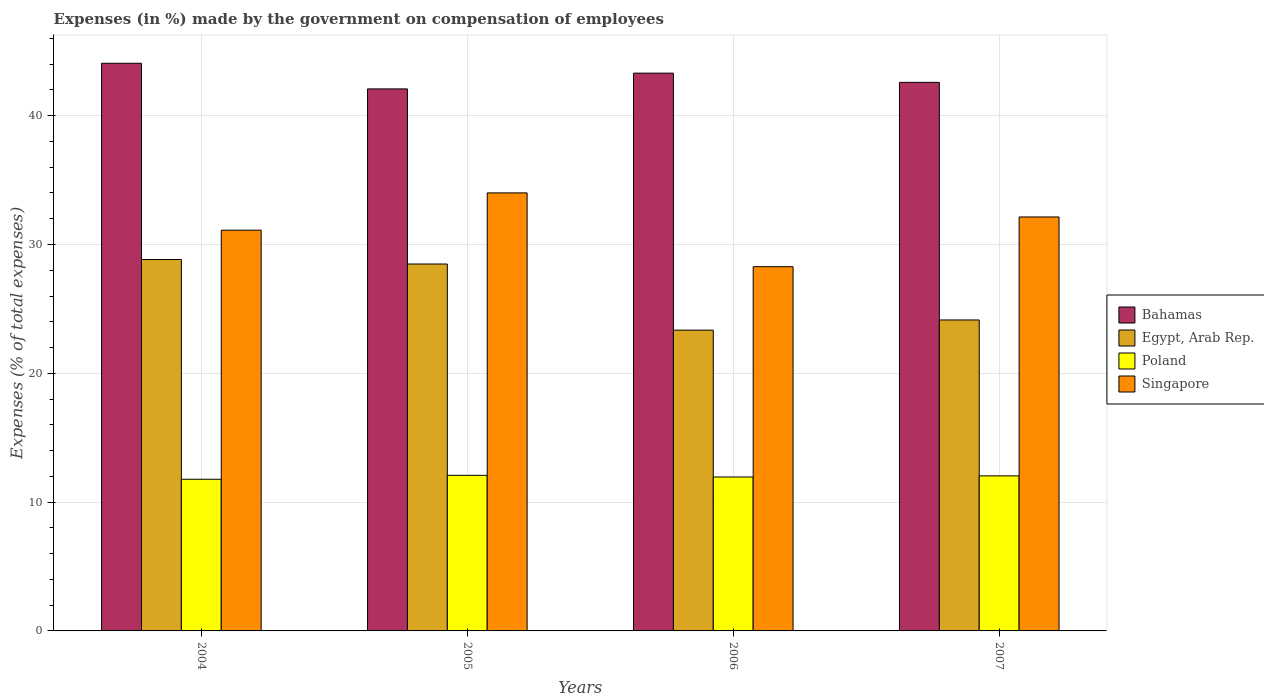How many different coloured bars are there?
Your response must be concise. 4. Are the number of bars on each tick of the X-axis equal?
Your answer should be compact. Yes. How many bars are there on the 1st tick from the left?
Provide a succinct answer. 4. How many bars are there on the 4th tick from the right?
Offer a very short reply. 4. What is the label of the 1st group of bars from the left?
Ensure brevity in your answer.  2004. In how many cases, is the number of bars for a given year not equal to the number of legend labels?
Your answer should be very brief. 0. What is the percentage of expenses made by the government on compensation of employees in Egypt, Arab Rep. in 2006?
Make the answer very short. 23.35. Across all years, what is the maximum percentage of expenses made by the government on compensation of employees in Bahamas?
Give a very brief answer. 44.07. Across all years, what is the minimum percentage of expenses made by the government on compensation of employees in Singapore?
Your answer should be compact. 28.28. In which year was the percentage of expenses made by the government on compensation of employees in Singapore minimum?
Give a very brief answer. 2006. What is the total percentage of expenses made by the government on compensation of employees in Egypt, Arab Rep. in the graph?
Your answer should be very brief. 104.81. What is the difference between the percentage of expenses made by the government on compensation of employees in Bahamas in 2005 and that in 2006?
Offer a very short reply. -1.22. What is the difference between the percentage of expenses made by the government on compensation of employees in Bahamas in 2007 and the percentage of expenses made by the government on compensation of employees in Singapore in 2006?
Make the answer very short. 14.31. What is the average percentage of expenses made by the government on compensation of employees in Singapore per year?
Provide a succinct answer. 31.38. In the year 2005, what is the difference between the percentage of expenses made by the government on compensation of employees in Poland and percentage of expenses made by the government on compensation of employees in Egypt, Arab Rep.?
Your response must be concise. -16.4. In how many years, is the percentage of expenses made by the government on compensation of employees in Egypt, Arab Rep. greater than 20 %?
Provide a succinct answer. 4. What is the ratio of the percentage of expenses made by the government on compensation of employees in Poland in 2006 to that in 2007?
Offer a terse response. 0.99. Is the percentage of expenses made by the government on compensation of employees in Bahamas in 2004 less than that in 2007?
Give a very brief answer. No. What is the difference between the highest and the second highest percentage of expenses made by the government on compensation of employees in Singapore?
Provide a short and direct response. 1.87. What is the difference between the highest and the lowest percentage of expenses made by the government on compensation of employees in Poland?
Make the answer very short. 0.31. Is the sum of the percentage of expenses made by the government on compensation of employees in Bahamas in 2004 and 2007 greater than the maximum percentage of expenses made by the government on compensation of employees in Singapore across all years?
Your answer should be compact. Yes. What does the 4th bar from the right in 2007 represents?
Your answer should be very brief. Bahamas. Are all the bars in the graph horizontal?
Your answer should be compact. No. Are the values on the major ticks of Y-axis written in scientific E-notation?
Give a very brief answer. No. Does the graph contain any zero values?
Keep it short and to the point. No. Where does the legend appear in the graph?
Keep it short and to the point. Center right. How many legend labels are there?
Offer a very short reply. 4. How are the legend labels stacked?
Your answer should be compact. Vertical. What is the title of the graph?
Give a very brief answer. Expenses (in %) made by the government on compensation of employees. What is the label or title of the Y-axis?
Give a very brief answer. Expenses (% of total expenses). What is the Expenses (% of total expenses) in Bahamas in 2004?
Your response must be concise. 44.07. What is the Expenses (% of total expenses) of Egypt, Arab Rep. in 2004?
Give a very brief answer. 28.84. What is the Expenses (% of total expenses) in Poland in 2004?
Keep it short and to the point. 11.77. What is the Expenses (% of total expenses) in Singapore in 2004?
Offer a terse response. 31.11. What is the Expenses (% of total expenses) in Bahamas in 2005?
Keep it short and to the point. 42.08. What is the Expenses (% of total expenses) of Egypt, Arab Rep. in 2005?
Ensure brevity in your answer.  28.48. What is the Expenses (% of total expenses) in Poland in 2005?
Your answer should be very brief. 12.08. What is the Expenses (% of total expenses) in Singapore in 2005?
Keep it short and to the point. 34.01. What is the Expenses (% of total expenses) of Bahamas in 2006?
Your answer should be compact. 43.3. What is the Expenses (% of total expenses) in Egypt, Arab Rep. in 2006?
Give a very brief answer. 23.35. What is the Expenses (% of total expenses) of Poland in 2006?
Provide a succinct answer. 11.95. What is the Expenses (% of total expenses) of Singapore in 2006?
Your answer should be very brief. 28.28. What is the Expenses (% of total expenses) of Bahamas in 2007?
Your answer should be compact. 42.59. What is the Expenses (% of total expenses) in Egypt, Arab Rep. in 2007?
Provide a succinct answer. 24.14. What is the Expenses (% of total expenses) in Poland in 2007?
Your response must be concise. 12.04. What is the Expenses (% of total expenses) in Singapore in 2007?
Offer a very short reply. 32.14. Across all years, what is the maximum Expenses (% of total expenses) in Bahamas?
Your answer should be very brief. 44.07. Across all years, what is the maximum Expenses (% of total expenses) of Egypt, Arab Rep.?
Make the answer very short. 28.84. Across all years, what is the maximum Expenses (% of total expenses) in Poland?
Provide a succinct answer. 12.08. Across all years, what is the maximum Expenses (% of total expenses) of Singapore?
Offer a very short reply. 34.01. Across all years, what is the minimum Expenses (% of total expenses) of Bahamas?
Provide a succinct answer. 42.08. Across all years, what is the minimum Expenses (% of total expenses) in Egypt, Arab Rep.?
Offer a very short reply. 23.35. Across all years, what is the minimum Expenses (% of total expenses) of Poland?
Provide a succinct answer. 11.77. Across all years, what is the minimum Expenses (% of total expenses) of Singapore?
Give a very brief answer. 28.28. What is the total Expenses (% of total expenses) of Bahamas in the graph?
Keep it short and to the point. 172.04. What is the total Expenses (% of total expenses) in Egypt, Arab Rep. in the graph?
Ensure brevity in your answer.  104.81. What is the total Expenses (% of total expenses) in Poland in the graph?
Offer a very short reply. 47.84. What is the total Expenses (% of total expenses) in Singapore in the graph?
Your answer should be very brief. 125.53. What is the difference between the Expenses (% of total expenses) in Bahamas in 2004 and that in 2005?
Keep it short and to the point. 1.99. What is the difference between the Expenses (% of total expenses) of Egypt, Arab Rep. in 2004 and that in 2005?
Keep it short and to the point. 0.35. What is the difference between the Expenses (% of total expenses) in Poland in 2004 and that in 2005?
Keep it short and to the point. -0.31. What is the difference between the Expenses (% of total expenses) in Singapore in 2004 and that in 2005?
Make the answer very short. -2.89. What is the difference between the Expenses (% of total expenses) of Bahamas in 2004 and that in 2006?
Your answer should be compact. 0.77. What is the difference between the Expenses (% of total expenses) of Egypt, Arab Rep. in 2004 and that in 2006?
Give a very brief answer. 5.49. What is the difference between the Expenses (% of total expenses) in Poland in 2004 and that in 2006?
Your response must be concise. -0.18. What is the difference between the Expenses (% of total expenses) in Singapore in 2004 and that in 2006?
Offer a terse response. 2.84. What is the difference between the Expenses (% of total expenses) in Bahamas in 2004 and that in 2007?
Your answer should be compact. 1.48. What is the difference between the Expenses (% of total expenses) of Egypt, Arab Rep. in 2004 and that in 2007?
Keep it short and to the point. 4.7. What is the difference between the Expenses (% of total expenses) in Poland in 2004 and that in 2007?
Your answer should be very brief. -0.26. What is the difference between the Expenses (% of total expenses) of Singapore in 2004 and that in 2007?
Ensure brevity in your answer.  -1.03. What is the difference between the Expenses (% of total expenses) of Bahamas in 2005 and that in 2006?
Offer a very short reply. -1.22. What is the difference between the Expenses (% of total expenses) in Egypt, Arab Rep. in 2005 and that in 2006?
Ensure brevity in your answer.  5.13. What is the difference between the Expenses (% of total expenses) in Poland in 2005 and that in 2006?
Your answer should be compact. 0.13. What is the difference between the Expenses (% of total expenses) in Singapore in 2005 and that in 2006?
Make the answer very short. 5.73. What is the difference between the Expenses (% of total expenses) of Bahamas in 2005 and that in 2007?
Give a very brief answer. -0.51. What is the difference between the Expenses (% of total expenses) in Egypt, Arab Rep. in 2005 and that in 2007?
Provide a succinct answer. 4.34. What is the difference between the Expenses (% of total expenses) in Poland in 2005 and that in 2007?
Your response must be concise. 0.04. What is the difference between the Expenses (% of total expenses) of Singapore in 2005 and that in 2007?
Your answer should be very brief. 1.87. What is the difference between the Expenses (% of total expenses) in Bahamas in 2006 and that in 2007?
Your response must be concise. 0.72. What is the difference between the Expenses (% of total expenses) of Egypt, Arab Rep. in 2006 and that in 2007?
Your answer should be very brief. -0.79. What is the difference between the Expenses (% of total expenses) in Poland in 2006 and that in 2007?
Make the answer very short. -0.09. What is the difference between the Expenses (% of total expenses) in Singapore in 2006 and that in 2007?
Your answer should be very brief. -3.86. What is the difference between the Expenses (% of total expenses) of Bahamas in 2004 and the Expenses (% of total expenses) of Egypt, Arab Rep. in 2005?
Make the answer very short. 15.59. What is the difference between the Expenses (% of total expenses) in Bahamas in 2004 and the Expenses (% of total expenses) in Poland in 2005?
Your answer should be very brief. 31.99. What is the difference between the Expenses (% of total expenses) of Bahamas in 2004 and the Expenses (% of total expenses) of Singapore in 2005?
Provide a succinct answer. 10.06. What is the difference between the Expenses (% of total expenses) of Egypt, Arab Rep. in 2004 and the Expenses (% of total expenses) of Poland in 2005?
Offer a very short reply. 16.76. What is the difference between the Expenses (% of total expenses) of Egypt, Arab Rep. in 2004 and the Expenses (% of total expenses) of Singapore in 2005?
Provide a short and direct response. -5.17. What is the difference between the Expenses (% of total expenses) in Poland in 2004 and the Expenses (% of total expenses) in Singapore in 2005?
Provide a succinct answer. -22.23. What is the difference between the Expenses (% of total expenses) in Bahamas in 2004 and the Expenses (% of total expenses) in Egypt, Arab Rep. in 2006?
Provide a succinct answer. 20.72. What is the difference between the Expenses (% of total expenses) in Bahamas in 2004 and the Expenses (% of total expenses) in Poland in 2006?
Provide a succinct answer. 32.12. What is the difference between the Expenses (% of total expenses) of Bahamas in 2004 and the Expenses (% of total expenses) of Singapore in 2006?
Your answer should be compact. 15.79. What is the difference between the Expenses (% of total expenses) of Egypt, Arab Rep. in 2004 and the Expenses (% of total expenses) of Poland in 2006?
Keep it short and to the point. 16.89. What is the difference between the Expenses (% of total expenses) in Egypt, Arab Rep. in 2004 and the Expenses (% of total expenses) in Singapore in 2006?
Provide a short and direct response. 0.56. What is the difference between the Expenses (% of total expenses) in Poland in 2004 and the Expenses (% of total expenses) in Singapore in 2006?
Your response must be concise. -16.5. What is the difference between the Expenses (% of total expenses) of Bahamas in 2004 and the Expenses (% of total expenses) of Egypt, Arab Rep. in 2007?
Make the answer very short. 19.93. What is the difference between the Expenses (% of total expenses) in Bahamas in 2004 and the Expenses (% of total expenses) in Poland in 2007?
Your response must be concise. 32.03. What is the difference between the Expenses (% of total expenses) in Bahamas in 2004 and the Expenses (% of total expenses) in Singapore in 2007?
Keep it short and to the point. 11.93. What is the difference between the Expenses (% of total expenses) in Egypt, Arab Rep. in 2004 and the Expenses (% of total expenses) in Poland in 2007?
Give a very brief answer. 16.8. What is the difference between the Expenses (% of total expenses) in Egypt, Arab Rep. in 2004 and the Expenses (% of total expenses) in Singapore in 2007?
Your answer should be compact. -3.3. What is the difference between the Expenses (% of total expenses) of Poland in 2004 and the Expenses (% of total expenses) of Singapore in 2007?
Your answer should be very brief. -20.36. What is the difference between the Expenses (% of total expenses) in Bahamas in 2005 and the Expenses (% of total expenses) in Egypt, Arab Rep. in 2006?
Ensure brevity in your answer.  18.73. What is the difference between the Expenses (% of total expenses) in Bahamas in 2005 and the Expenses (% of total expenses) in Poland in 2006?
Offer a very short reply. 30.13. What is the difference between the Expenses (% of total expenses) of Bahamas in 2005 and the Expenses (% of total expenses) of Singapore in 2006?
Ensure brevity in your answer.  13.8. What is the difference between the Expenses (% of total expenses) in Egypt, Arab Rep. in 2005 and the Expenses (% of total expenses) in Poland in 2006?
Give a very brief answer. 16.53. What is the difference between the Expenses (% of total expenses) of Egypt, Arab Rep. in 2005 and the Expenses (% of total expenses) of Singapore in 2006?
Provide a short and direct response. 0.21. What is the difference between the Expenses (% of total expenses) in Poland in 2005 and the Expenses (% of total expenses) in Singapore in 2006?
Ensure brevity in your answer.  -16.2. What is the difference between the Expenses (% of total expenses) in Bahamas in 2005 and the Expenses (% of total expenses) in Egypt, Arab Rep. in 2007?
Provide a short and direct response. 17.94. What is the difference between the Expenses (% of total expenses) of Bahamas in 2005 and the Expenses (% of total expenses) of Poland in 2007?
Keep it short and to the point. 30.04. What is the difference between the Expenses (% of total expenses) of Bahamas in 2005 and the Expenses (% of total expenses) of Singapore in 2007?
Your response must be concise. 9.94. What is the difference between the Expenses (% of total expenses) of Egypt, Arab Rep. in 2005 and the Expenses (% of total expenses) of Poland in 2007?
Keep it short and to the point. 16.45. What is the difference between the Expenses (% of total expenses) in Egypt, Arab Rep. in 2005 and the Expenses (% of total expenses) in Singapore in 2007?
Provide a short and direct response. -3.65. What is the difference between the Expenses (% of total expenses) of Poland in 2005 and the Expenses (% of total expenses) of Singapore in 2007?
Your answer should be very brief. -20.06. What is the difference between the Expenses (% of total expenses) in Bahamas in 2006 and the Expenses (% of total expenses) in Egypt, Arab Rep. in 2007?
Offer a terse response. 19.16. What is the difference between the Expenses (% of total expenses) in Bahamas in 2006 and the Expenses (% of total expenses) in Poland in 2007?
Provide a succinct answer. 31.27. What is the difference between the Expenses (% of total expenses) in Bahamas in 2006 and the Expenses (% of total expenses) in Singapore in 2007?
Offer a very short reply. 11.17. What is the difference between the Expenses (% of total expenses) of Egypt, Arab Rep. in 2006 and the Expenses (% of total expenses) of Poland in 2007?
Keep it short and to the point. 11.31. What is the difference between the Expenses (% of total expenses) in Egypt, Arab Rep. in 2006 and the Expenses (% of total expenses) in Singapore in 2007?
Provide a short and direct response. -8.79. What is the difference between the Expenses (% of total expenses) of Poland in 2006 and the Expenses (% of total expenses) of Singapore in 2007?
Your answer should be compact. -20.19. What is the average Expenses (% of total expenses) in Bahamas per year?
Keep it short and to the point. 43.01. What is the average Expenses (% of total expenses) of Egypt, Arab Rep. per year?
Ensure brevity in your answer.  26.2. What is the average Expenses (% of total expenses) in Poland per year?
Ensure brevity in your answer.  11.96. What is the average Expenses (% of total expenses) of Singapore per year?
Your answer should be compact. 31.38. In the year 2004, what is the difference between the Expenses (% of total expenses) in Bahamas and Expenses (% of total expenses) in Egypt, Arab Rep.?
Provide a succinct answer. 15.23. In the year 2004, what is the difference between the Expenses (% of total expenses) of Bahamas and Expenses (% of total expenses) of Poland?
Offer a terse response. 32.3. In the year 2004, what is the difference between the Expenses (% of total expenses) of Bahamas and Expenses (% of total expenses) of Singapore?
Your response must be concise. 12.96. In the year 2004, what is the difference between the Expenses (% of total expenses) of Egypt, Arab Rep. and Expenses (% of total expenses) of Poland?
Your answer should be compact. 17.06. In the year 2004, what is the difference between the Expenses (% of total expenses) in Egypt, Arab Rep. and Expenses (% of total expenses) in Singapore?
Provide a succinct answer. -2.28. In the year 2004, what is the difference between the Expenses (% of total expenses) in Poland and Expenses (% of total expenses) in Singapore?
Ensure brevity in your answer.  -19.34. In the year 2005, what is the difference between the Expenses (% of total expenses) of Bahamas and Expenses (% of total expenses) of Egypt, Arab Rep.?
Give a very brief answer. 13.6. In the year 2005, what is the difference between the Expenses (% of total expenses) of Bahamas and Expenses (% of total expenses) of Singapore?
Your answer should be compact. 8.07. In the year 2005, what is the difference between the Expenses (% of total expenses) of Egypt, Arab Rep. and Expenses (% of total expenses) of Poland?
Your response must be concise. 16.4. In the year 2005, what is the difference between the Expenses (% of total expenses) of Egypt, Arab Rep. and Expenses (% of total expenses) of Singapore?
Offer a terse response. -5.52. In the year 2005, what is the difference between the Expenses (% of total expenses) of Poland and Expenses (% of total expenses) of Singapore?
Provide a short and direct response. -21.93. In the year 2006, what is the difference between the Expenses (% of total expenses) in Bahamas and Expenses (% of total expenses) in Egypt, Arab Rep.?
Your answer should be very brief. 19.95. In the year 2006, what is the difference between the Expenses (% of total expenses) of Bahamas and Expenses (% of total expenses) of Poland?
Make the answer very short. 31.35. In the year 2006, what is the difference between the Expenses (% of total expenses) of Bahamas and Expenses (% of total expenses) of Singapore?
Provide a succinct answer. 15.03. In the year 2006, what is the difference between the Expenses (% of total expenses) in Egypt, Arab Rep. and Expenses (% of total expenses) in Poland?
Ensure brevity in your answer.  11.4. In the year 2006, what is the difference between the Expenses (% of total expenses) of Egypt, Arab Rep. and Expenses (% of total expenses) of Singapore?
Provide a short and direct response. -4.93. In the year 2006, what is the difference between the Expenses (% of total expenses) in Poland and Expenses (% of total expenses) in Singapore?
Provide a short and direct response. -16.33. In the year 2007, what is the difference between the Expenses (% of total expenses) of Bahamas and Expenses (% of total expenses) of Egypt, Arab Rep.?
Give a very brief answer. 18.45. In the year 2007, what is the difference between the Expenses (% of total expenses) in Bahamas and Expenses (% of total expenses) in Poland?
Provide a succinct answer. 30.55. In the year 2007, what is the difference between the Expenses (% of total expenses) in Bahamas and Expenses (% of total expenses) in Singapore?
Ensure brevity in your answer.  10.45. In the year 2007, what is the difference between the Expenses (% of total expenses) in Egypt, Arab Rep. and Expenses (% of total expenses) in Poland?
Keep it short and to the point. 12.1. In the year 2007, what is the difference between the Expenses (% of total expenses) in Egypt, Arab Rep. and Expenses (% of total expenses) in Singapore?
Your response must be concise. -8. In the year 2007, what is the difference between the Expenses (% of total expenses) of Poland and Expenses (% of total expenses) of Singapore?
Your answer should be very brief. -20.1. What is the ratio of the Expenses (% of total expenses) of Bahamas in 2004 to that in 2005?
Make the answer very short. 1.05. What is the ratio of the Expenses (% of total expenses) in Egypt, Arab Rep. in 2004 to that in 2005?
Offer a terse response. 1.01. What is the ratio of the Expenses (% of total expenses) in Poland in 2004 to that in 2005?
Offer a terse response. 0.97. What is the ratio of the Expenses (% of total expenses) in Singapore in 2004 to that in 2005?
Make the answer very short. 0.91. What is the ratio of the Expenses (% of total expenses) in Bahamas in 2004 to that in 2006?
Offer a terse response. 1.02. What is the ratio of the Expenses (% of total expenses) of Egypt, Arab Rep. in 2004 to that in 2006?
Your answer should be compact. 1.23. What is the ratio of the Expenses (% of total expenses) of Singapore in 2004 to that in 2006?
Keep it short and to the point. 1.1. What is the ratio of the Expenses (% of total expenses) in Bahamas in 2004 to that in 2007?
Your answer should be very brief. 1.03. What is the ratio of the Expenses (% of total expenses) in Egypt, Arab Rep. in 2004 to that in 2007?
Offer a terse response. 1.19. What is the ratio of the Expenses (% of total expenses) in Poland in 2004 to that in 2007?
Your response must be concise. 0.98. What is the ratio of the Expenses (% of total expenses) of Singapore in 2004 to that in 2007?
Your response must be concise. 0.97. What is the ratio of the Expenses (% of total expenses) of Bahamas in 2005 to that in 2006?
Your answer should be compact. 0.97. What is the ratio of the Expenses (% of total expenses) of Egypt, Arab Rep. in 2005 to that in 2006?
Give a very brief answer. 1.22. What is the ratio of the Expenses (% of total expenses) in Poland in 2005 to that in 2006?
Your response must be concise. 1.01. What is the ratio of the Expenses (% of total expenses) of Singapore in 2005 to that in 2006?
Offer a very short reply. 1.2. What is the ratio of the Expenses (% of total expenses) in Bahamas in 2005 to that in 2007?
Make the answer very short. 0.99. What is the ratio of the Expenses (% of total expenses) of Egypt, Arab Rep. in 2005 to that in 2007?
Offer a very short reply. 1.18. What is the ratio of the Expenses (% of total expenses) of Singapore in 2005 to that in 2007?
Your answer should be very brief. 1.06. What is the ratio of the Expenses (% of total expenses) of Bahamas in 2006 to that in 2007?
Provide a succinct answer. 1.02. What is the ratio of the Expenses (% of total expenses) in Egypt, Arab Rep. in 2006 to that in 2007?
Give a very brief answer. 0.97. What is the ratio of the Expenses (% of total expenses) of Poland in 2006 to that in 2007?
Your answer should be compact. 0.99. What is the ratio of the Expenses (% of total expenses) of Singapore in 2006 to that in 2007?
Offer a terse response. 0.88. What is the difference between the highest and the second highest Expenses (% of total expenses) in Bahamas?
Offer a very short reply. 0.77. What is the difference between the highest and the second highest Expenses (% of total expenses) in Egypt, Arab Rep.?
Ensure brevity in your answer.  0.35. What is the difference between the highest and the second highest Expenses (% of total expenses) of Poland?
Offer a very short reply. 0.04. What is the difference between the highest and the second highest Expenses (% of total expenses) in Singapore?
Your answer should be very brief. 1.87. What is the difference between the highest and the lowest Expenses (% of total expenses) of Bahamas?
Your response must be concise. 1.99. What is the difference between the highest and the lowest Expenses (% of total expenses) in Egypt, Arab Rep.?
Provide a short and direct response. 5.49. What is the difference between the highest and the lowest Expenses (% of total expenses) in Poland?
Give a very brief answer. 0.31. What is the difference between the highest and the lowest Expenses (% of total expenses) of Singapore?
Provide a succinct answer. 5.73. 